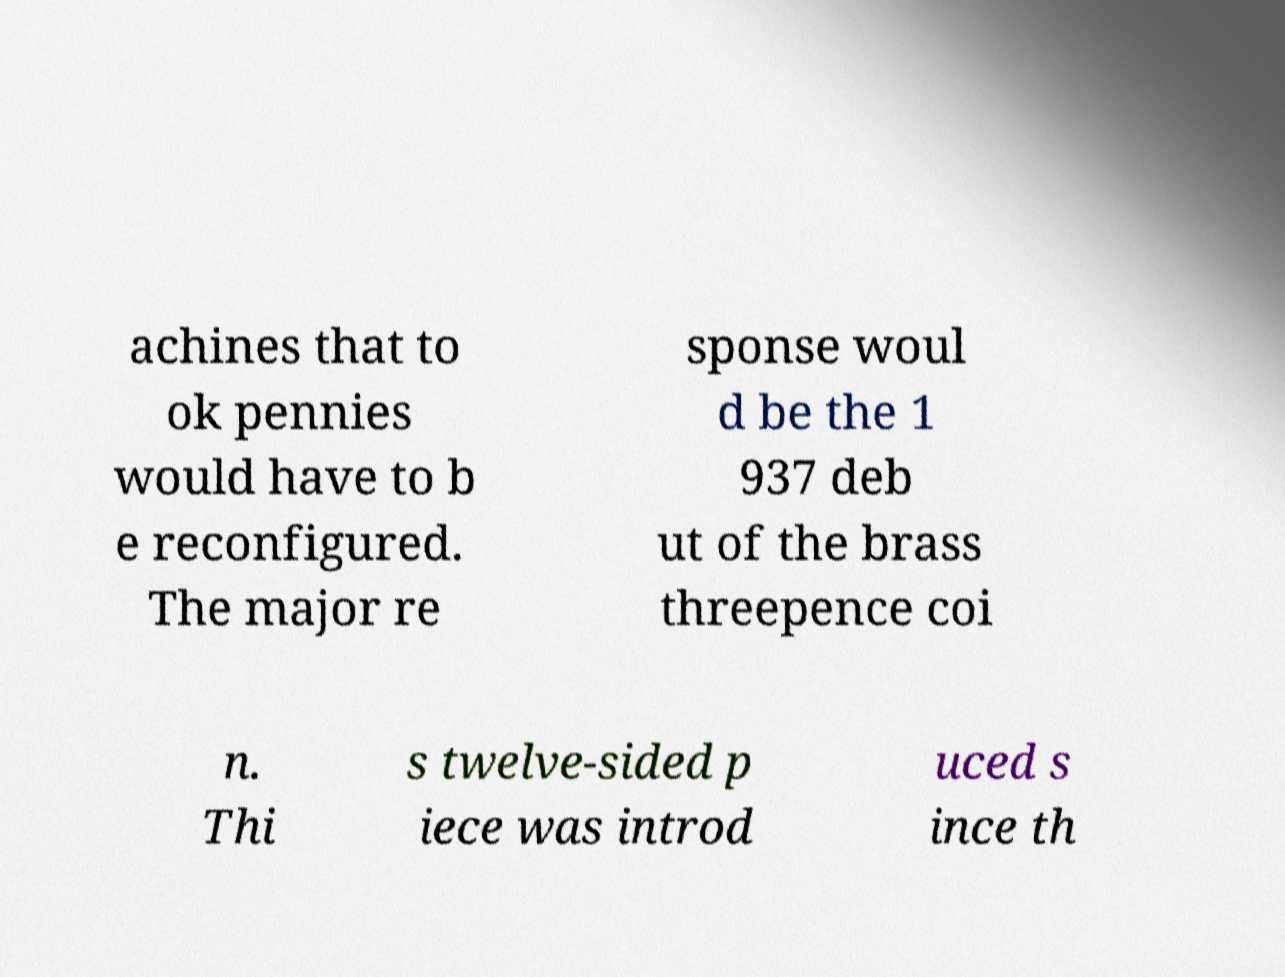Could you extract and type out the text from this image? achines that to ok pennies would have to b e reconfigured. The major re sponse woul d be the 1 937 deb ut of the brass threepence coi n. Thi s twelve-sided p iece was introd uced s ince th 